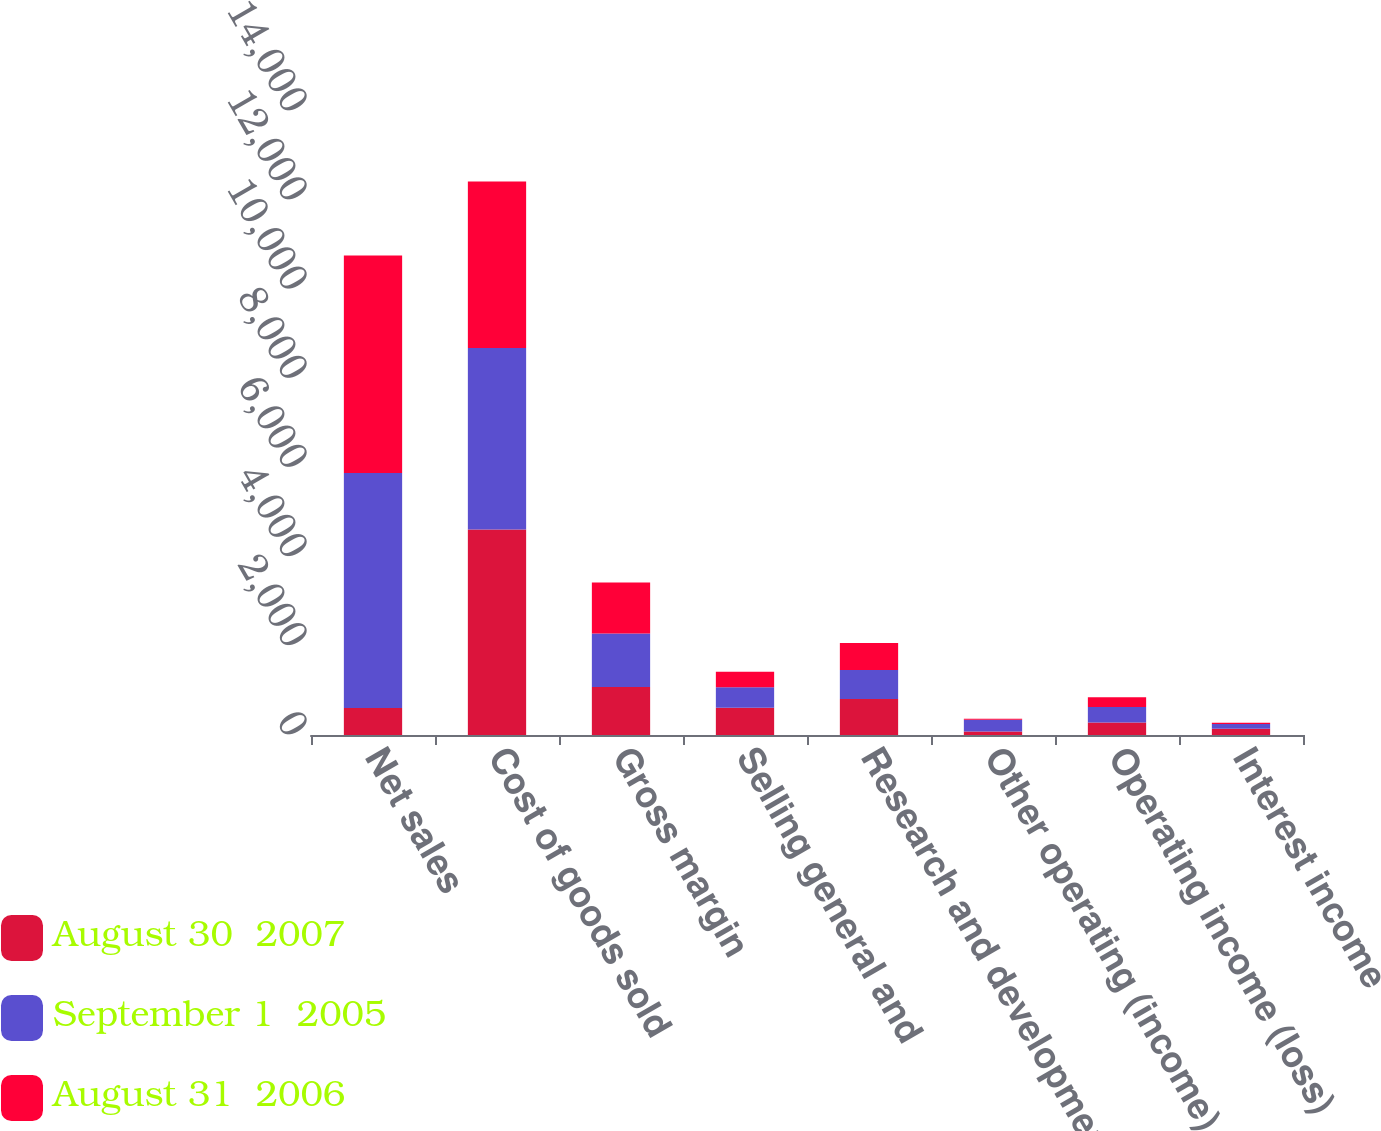Convert chart. <chart><loc_0><loc_0><loc_500><loc_500><stacked_bar_chart><ecel><fcel>Net sales<fcel>Cost of goods sold<fcel>Gross margin<fcel>Selling general and<fcel>Research and development<fcel>Other operating (income)<fcel>Operating income (loss)<fcel>Interest income<nl><fcel>August 30  2007<fcel>604<fcel>4610<fcel>1078<fcel>610<fcel>805<fcel>76<fcel>280<fcel>143<nl><fcel>September 1  2005<fcel>5272<fcel>4072<fcel>1200<fcel>460<fcel>656<fcel>266<fcel>350<fcel>101<nl><fcel>August 31  2006<fcel>4880<fcel>3734<fcel>1146<fcel>348<fcel>604<fcel>22<fcel>217<fcel>32<nl></chart> 